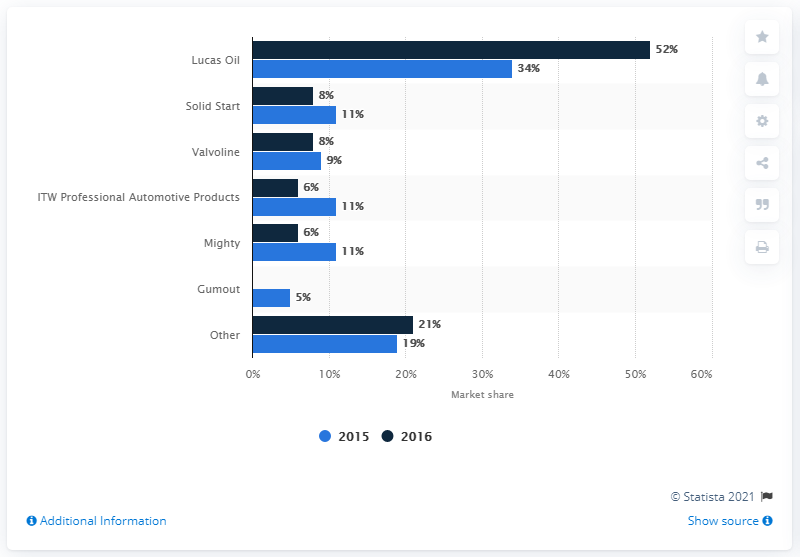Outline some significant characteristics in this image. According to a report released in 2016, Lucas Oil held a market share of 52% in the United States. Lucas Oil was the fuel additive that captured the most market share from 2015 to 2016. In 2015, Valvoline held 8% of the fuel additive market share, and in 2016, this percentage increased to 9%. These figures suggest that Valvoline was a prominent player in the fuel additive market during this time period. 